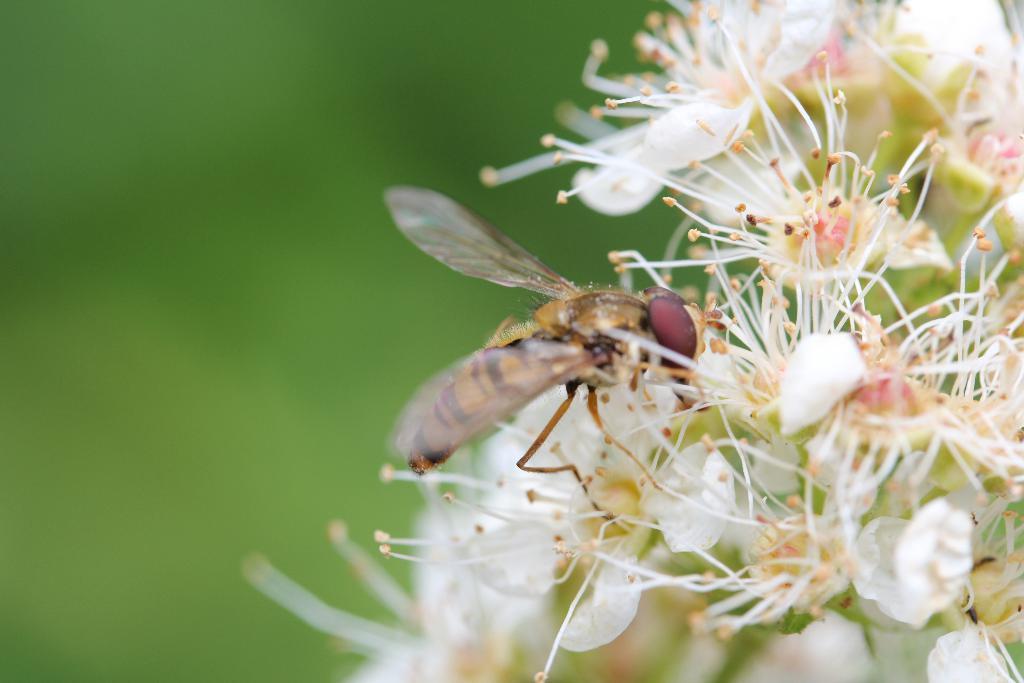In one or two sentences, can you explain what this image depicts? On the right side of this image there are few white color flowers. On the flowers there is a fly. The background is blurred. 